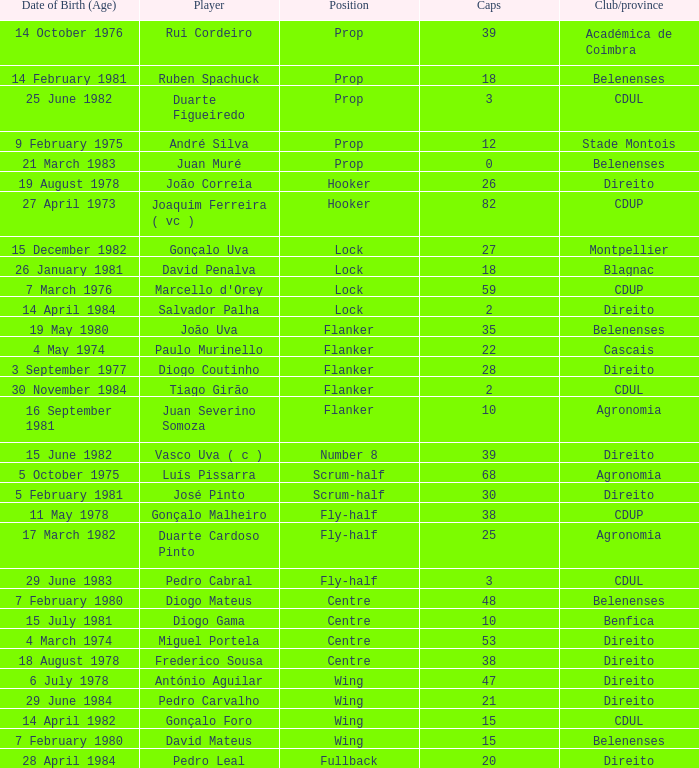Which player has a Club/province of direito, less than 21 caps, and a Position of lock? Salvador Palha. 